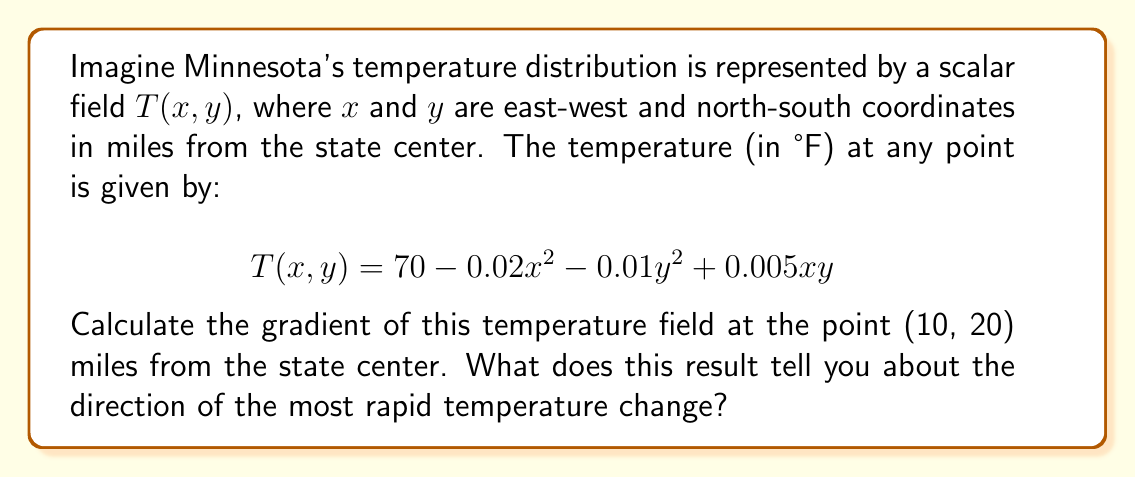Help me with this question. To solve this problem, we'll follow these steps:

1) The gradient of a scalar field $T(x,y)$ is defined as:

   $$\nabla T = \left(\frac{\partial T}{\partial x}, \frac{\partial T}{\partial y}\right)$$

2) We need to calculate the partial derivatives:

   $\frac{\partial T}{\partial x} = -0.04x + 0.005y$
   $\frac{\partial T}{\partial y} = -0.02y + 0.005x$

3) Now, we substitute the given point (10, 20) into these partial derivatives:

   $\frac{\partial T}{\partial x}|_{(10,20)} = -0.04(10) + 0.005(20) = -0.3$
   $\frac{\partial T}{\partial y}|_{(10,20)} = -0.02(20) + 0.005(10) = -0.35$

4) Therefore, the gradient at (10, 20) is:

   $$\nabla T|_{(10,20)} = (-0.3, -0.35)$$

5) The magnitude of this gradient vector is:

   $$|\nabla T|_{(10,20)}| = \sqrt{(-0.3)^2 + (-0.35)^2} \approx 0.46$$

6) The direction of the gradient points in the direction of steepest increase of the temperature field. In this case, the gradient is pointing southwest (both components are negative).

7) The negative of the gradient (-0.3, -0.35) points northeast, indicating the direction of most rapid temperature increase.
Answer: $\nabla T|_{(10,20)} = (-0.3, -0.35)$, pointing southwest; temperature increases most rapidly northeast. 